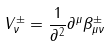Convert formula to latex. <formula><loc_0><loc_0><loc_500><loc_500>V ^ { \pm } _ { \nu } = \frac { 1 } { \partial ^ { 2 } } \partial ^ { \mu } \beta ^ { \pm } _ { \mu \nu }</formula> 